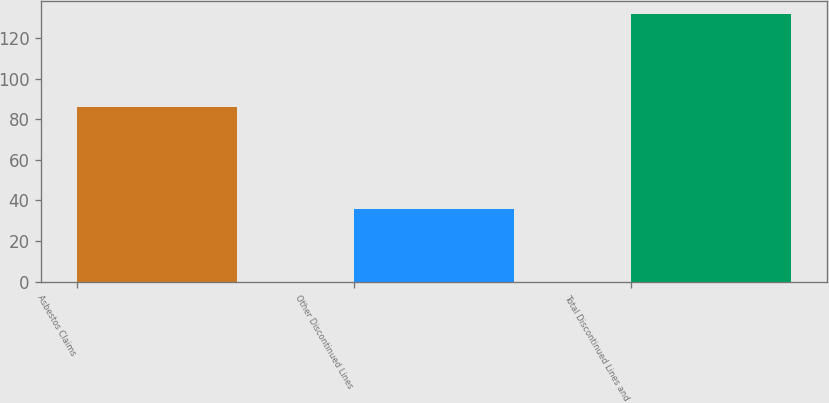<chart> <loc_0><loc_0><loc_500><loc_500><bar_chart><fcel>Asbestos Claims<fcel>Other Discontinued Lines<fcel>Total Discontinued Lines and<nl><fcel>86<fcel>36<fcel>132<nl></chart> 